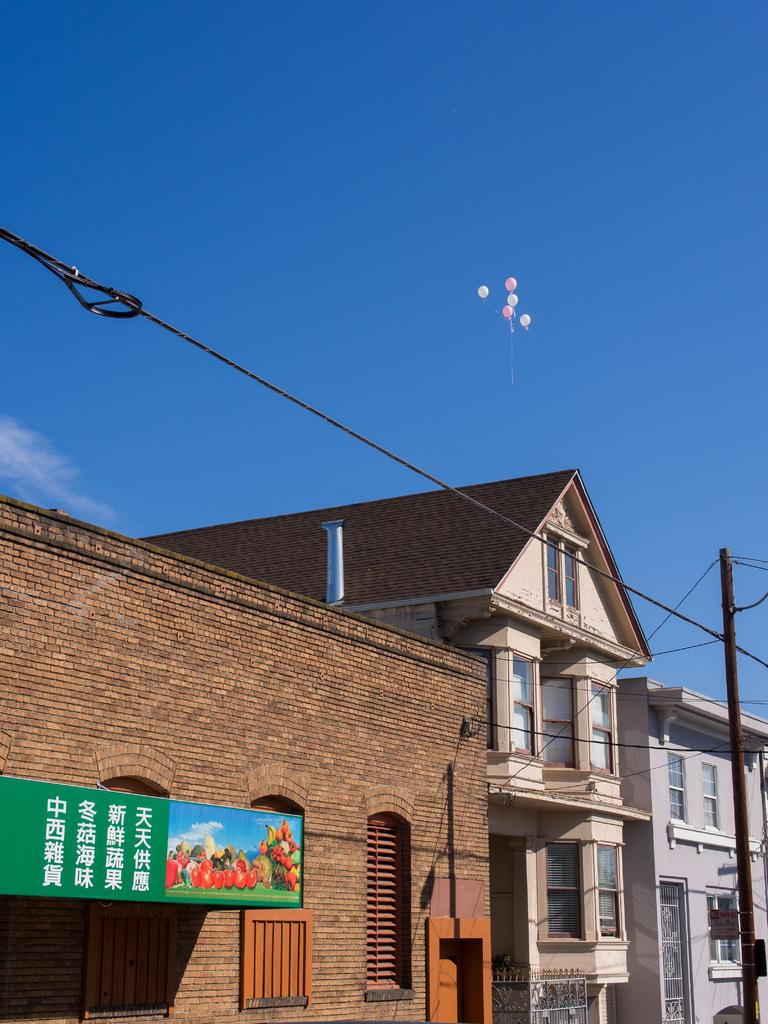What type of structures are located at the bottom of the image? There are buildings at the bottom of the image. What additional objects can be seen in the image? There are balloons in the image. Where is the pole located in the image? The pole is on the right side of the image. What color is the sky in the image? The blue sky is at the top of the image. What word is written on the bottle in the image? There is no bottle present in the image, so it is not possible to answer that question. 